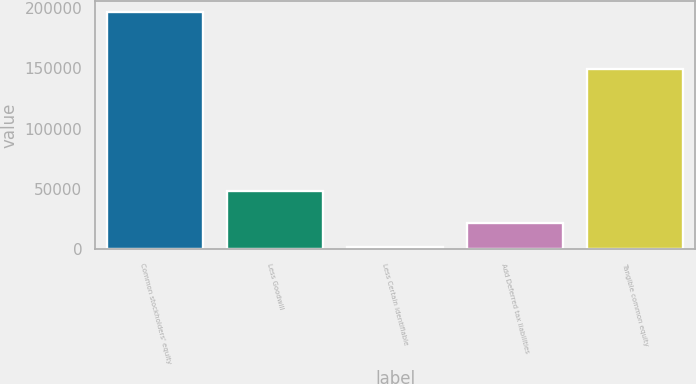<chart> <loc_0><loc_0><loc_500><loc_500><bar_chart><fcel>Common stockholders' equity<fcel>Less Goodwill<fcel>Less Certain identifiable<fcel>Add Deferred tax liabilities<fcel>Tangible common equity<nl><fcel>196409<fcel>48102<fcel>1950<fcel>21395.9<fcel>149242<nl></chart> 